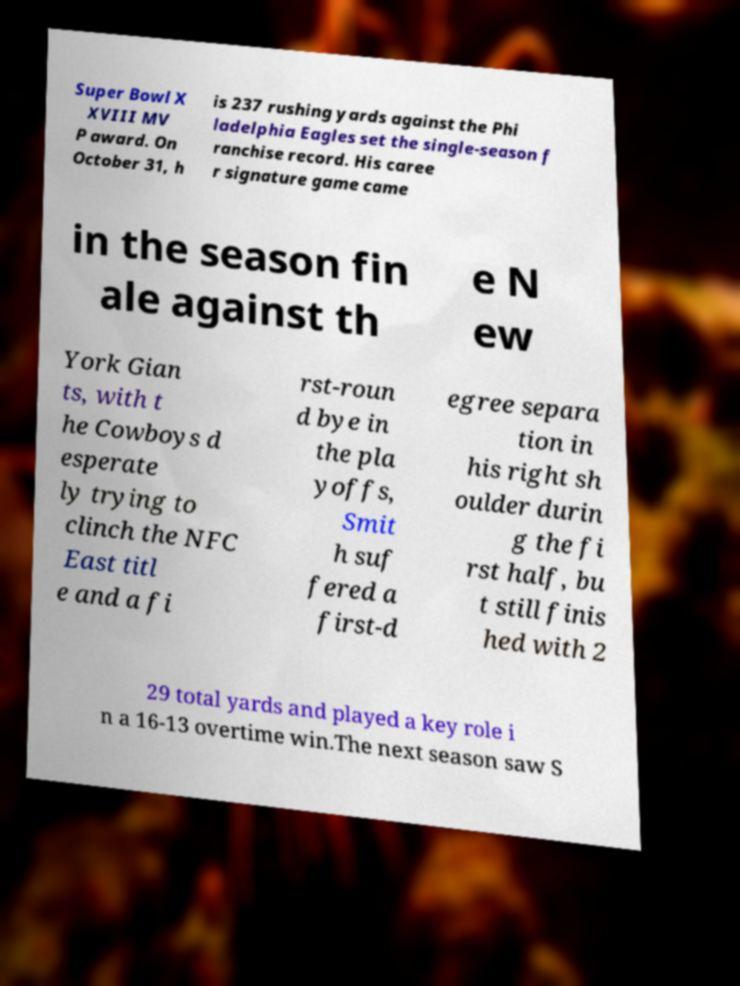There's text embedded in this image that I need extracted. Can you transcribe it verbatim? Super Bowl X XVIII MV P award. On October 31, h is 237 rushing yards against the Phi ladelphia Eagles set the single-season f ranchise record. His caree r signature game came in the season fin ale against th e N ew York Gian ts, with t he Cowboys d esperate ly trying to clinch the NFC East titl e and a fi rst-roun d bye in the pla yoffs, Smit h suf fered a first-d egree separa tion in his right sh oulder durin g the fi rst half, bu t still finis hed with 2 29 total yards and played a key role i n a 16-13 overtime win.The next season saw S 